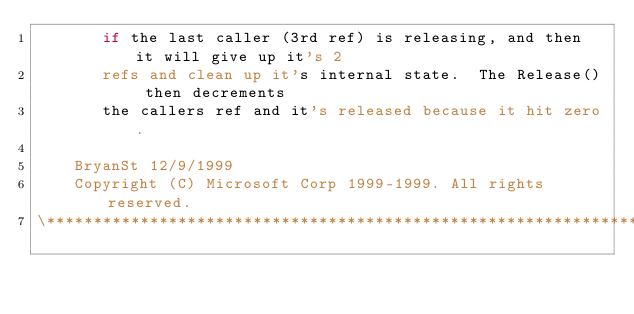Convert code to text. <code><loc_0><loc_0><loc_500><loc_500><_C_>       if the last caller (3rd ref) is releasing, and then it will give up it's 2
       refs and clean up it's internal state.  The Release() then decrements
       the callers ref and it's released because it hit zero.

    BryanSt 12/9/1999
    Copyright (C) Microsoft Corp 1999-1999. All rights reserved.
\*****************************************************************************/
</code> 